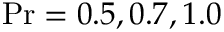<formula> <loc_0><loc_0><loc_500><loc_500>P r = 0 . 5 , 0 . 7 , 1 . 0</formula> 